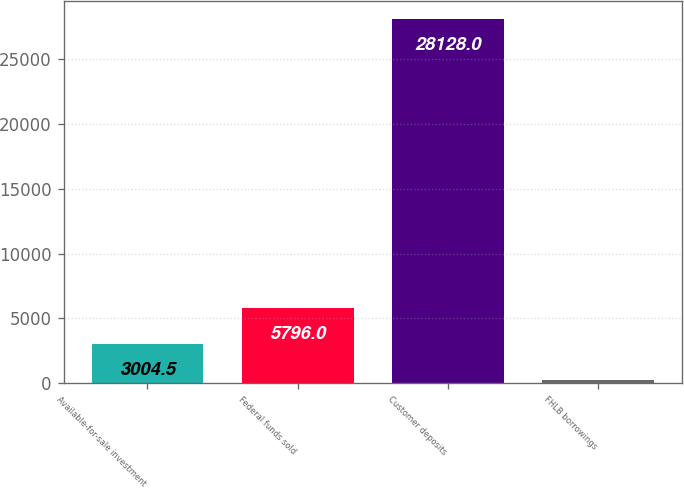<chart> <loc_0><loc_0><loc_500><loc_500><bar_chart><fcel>Available-for-sale investment<fcel>Federal funds sold<fcel>Customer deposits<fcel>FHLB borrowings<nl><fcel>3004.5<fcel>5796<fcel>28128<fcel>213<nl></chart> 